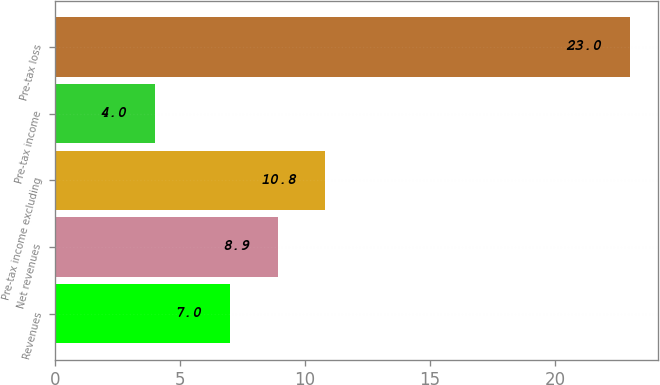Convert chart to OTSL. <chart><loc_0><loc_0><loc_500><loc_500><bar_chart><fcel>Revenues<fcel>Net revenues<fcel>Pre-tax income excluding<fcel>Pre-tax income<fcel>Pre-tax loss<nl><fcel>7<fcel>8.9<fcel>10.8<fcel>4<fcel>23<nl></chart> 